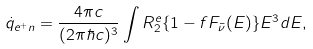<formula> <loc_0><loc_0><loc_500><loc_500>\dot { q } _ { e ^ { + } n } = \frac { 4 \pi c } { ( 2 \pi \hbar { c } ) ^ { 3 } } \int R ^ { e } _ { 2 } \{ 1 - f F _ { \bar { \nu } } ( E ) \} E ^ { 3 } d E ,</formula> 